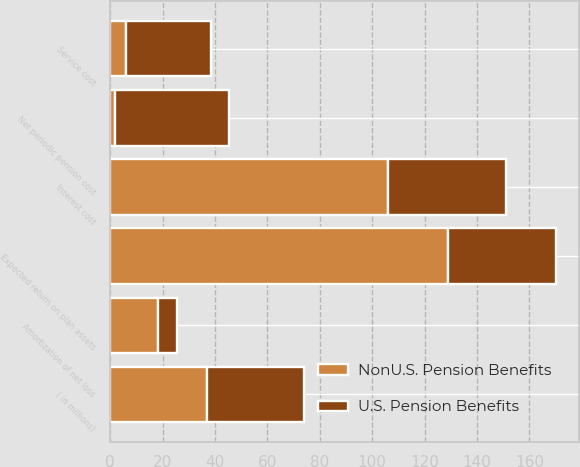Convert chart. <chart><loc_0><loc_0><loc_500><loc_500><stacked_bar_chart><ecel><fcel>( in millions)<fcel>Service cost<fcel>Interest cost<fcel>Expected return on plan assets<fcel>Amortization of net loss<fcel>Net periodic pension cost<nl><fcel>NonU.S. Pension Benefits<fcel>36.95<fcel>6<fcel>105.9<fcel>128.8<fcel>18.4<fcel>1.7<nl><fcel>U.S. Pension Benefits<fcel>36.95<fcel>32.4<fcel>45.2<fcel>41.5<fcel>7<fcel>43.7<nl></chart> 